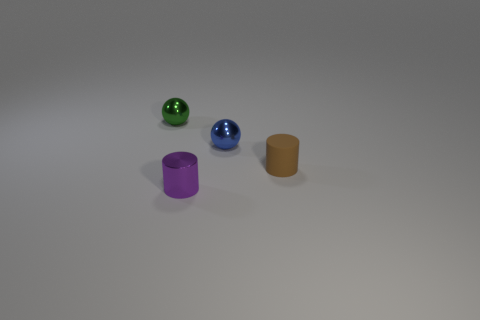What color is the small cylinder that is the same material as the small blue object?
Ensure brevity in your answer.  Purple. Is the material of the small purple cylinder the same as the small sphere on the right side of the tiny purple cylinder?
Provide a short and direct response. Yes. What number of things are tiny blue metallic balls or yellow matte things?
Ensure brevity in your answer.  1. Are there any tiny purple shiny things that have the same shape as the tiny brown rubber thing?
Ensure brevity in your answer.  Yes. How many green balls are in front of the blue thing?
Make the answer very short. 0. What material is the cylinder behind the tiny cylinder that is in front of the tiny rubber thing?
Offer a very short reply. Rubber. There is a purple cylinder that is the same size as the blue sphere; what material is it?
Offer a terse response. Metal. Are there any purple cylinders of the same size as the blue metal object?
Your answer should be very brief. Yes. The small cylinder that is behind the metallic cylinder is what color?
Offer a very short reply. Brown. There is a ball that is right of the green sphere; are there any tiny shiny objects that are behind it?
Give a very brief answer. Yes. 